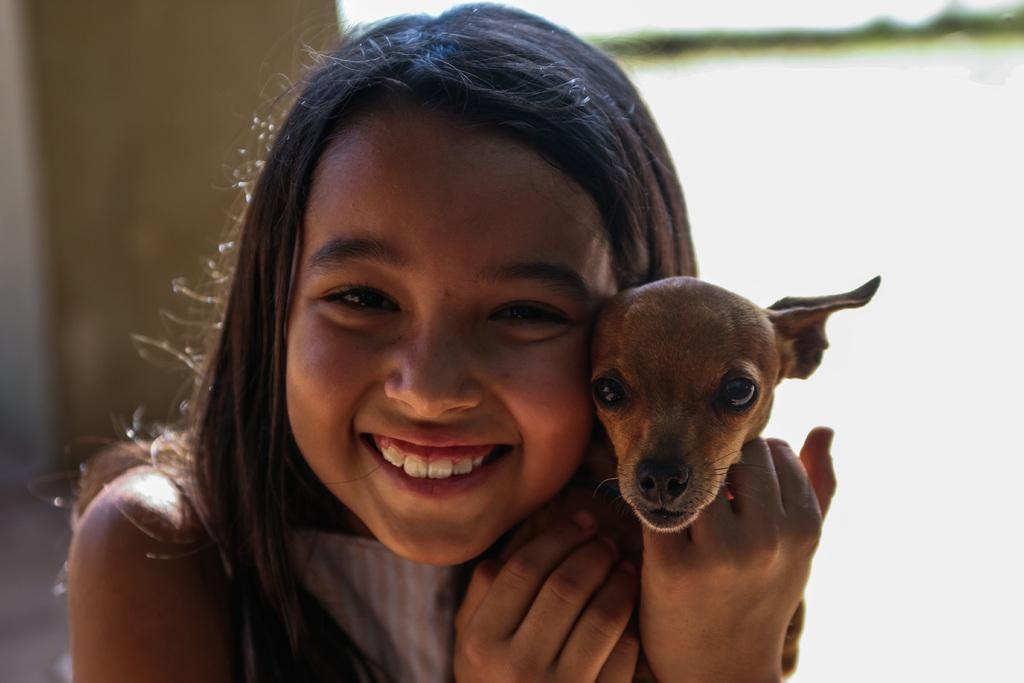Who is the main subject in the image? There is a small girl in the image. What is the girl doing in the image? The girl is smiling in the image. What is the girl holding in the image? The girl is holding a puppy in the image. What can be seen in the background of the image? There is a wall in the background of the image. What type of plate is being used to serve the blood in the image? There is no plate or blood present in the image; it features a small girl holding a puppy. 